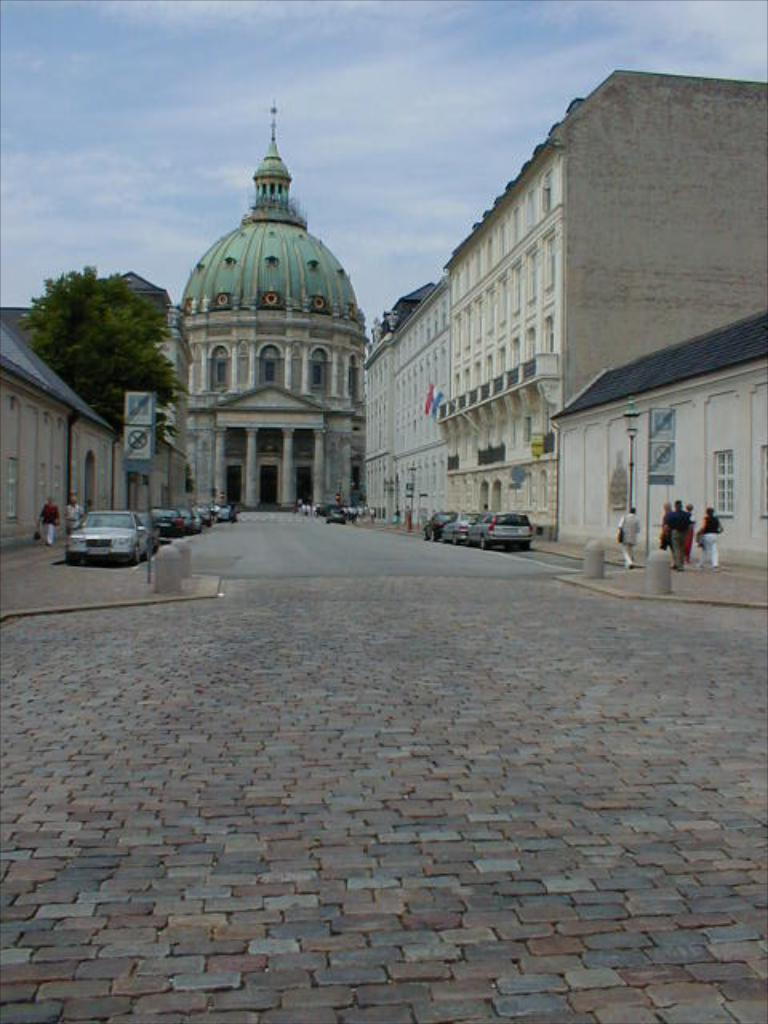What is the main feature of the image? There is a road in the image. What else can be seen on the road? There are vehicles in the image. Are there any signs or directions provided in the image? Yes, there are sign boards in the image. What type of structures are visible in the image? There are buildings in the image. Can you identify any natural elements in the image? Yes, there is a tree in the image. Are there any people present in the image? Yes, there are people standing in the image. What can be seen in the background of the image? The sky is visible in the background of the image, and there are clouds present. Reasoning: Let's think step by step by step in order to produce the conversation. We start by identifying the main feature of the image, which is the road. Then, we expand the conversation to include other elements that are also visible, such as vehicles, sign boards, buildings, a tree, people, and the sky with clouds in the background. Each question is designed to elicit a specific detail about the image that is known from the provided facts. Absurd Question/Answer: What type of tooth is visible in the image? There is no tooth present in the image. Can you identify the parent of the person standing in the image? There is no information about the person's parent in the image. 